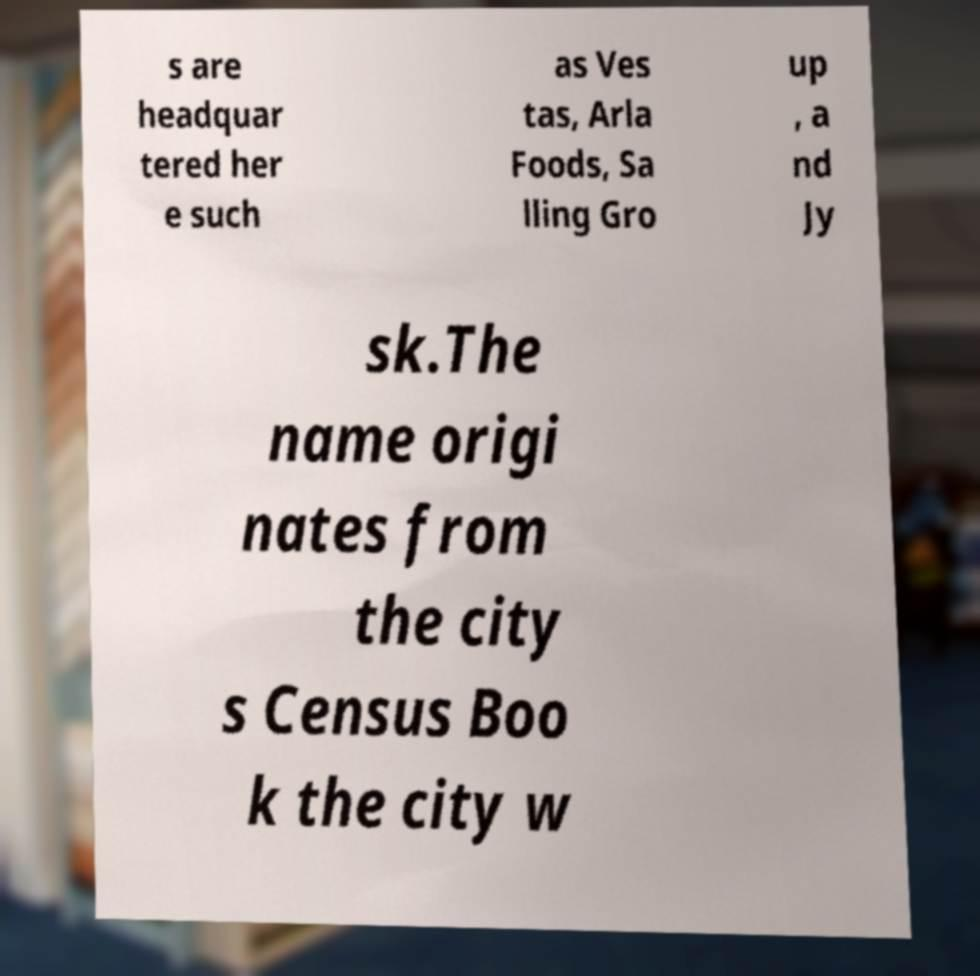Can you read and provide the text displayed in the image?This photo seems to have some interesting text. Can you extract and type it out for me? s are headquar tered her e such as Ves tas, Arla Foods, Sa lling Gro up , a nd Jy sk.The name origi nates from the city s Census Boo k the city w 